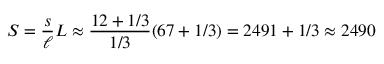<formula> <loc_0><loc_0><loc_500><loc_500>S = { \frac { s } { \ell } } L \approx { \frac { 1 2 + 1 / 3 } { 1 / 3 } } ( 6 7 + 1 / 3 ) = 2 4 9 1 + 1 / 3 \approx 2 4 9 0</formula> 